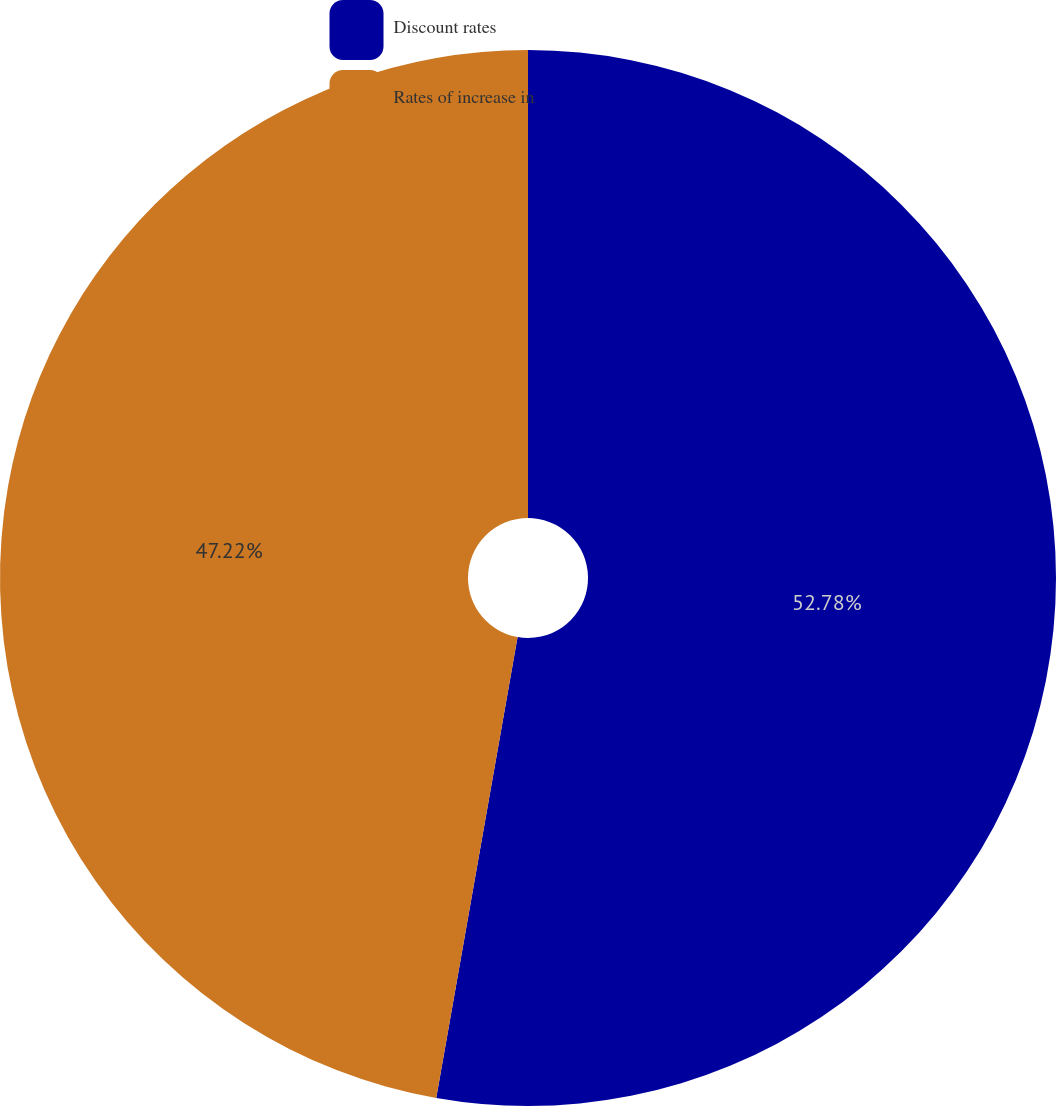<chart> <loc_0><loc_0><loc_500><loc_500><pie_chart><fcel>Discount rates<fcel>Rates of increase in<nl><fcel>52.78%<fcel>47.22%<nl></chart> 